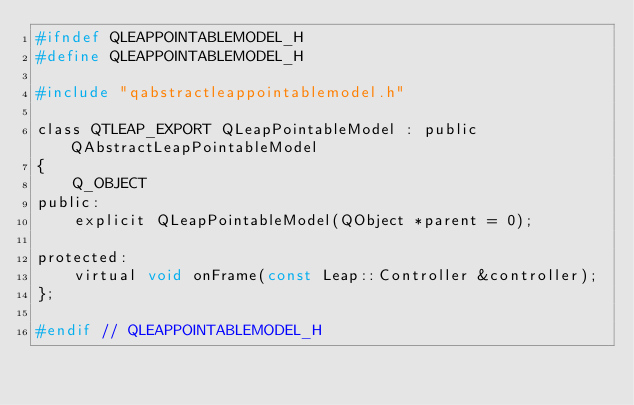<code> <loc_0><loc_0><loc_500><loc_500><_C_>#ifndef QLEAPPOINTABLEMODEL_H
#define QLEAPPOINTABLEMODEL_H

#include "qabstractleappointablemodel.h"

class QTLEAP_EXPORT QLeapPointableModel : public QAbstractLeapPointableModel
{
    Q_OBJECT
public:
    explicit QLeapPointableModel(QObject *parent = 0);

protected:
    virtual void onFrame(const Leap::Controller &controller);
};

#endif // QLEAPPOINTABLEMODEL_H
</code> 